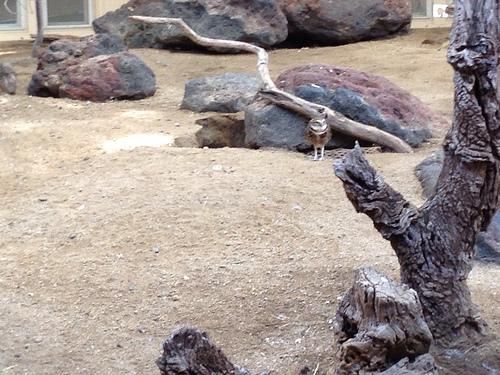Question: how many people are there?
Choices:
A. 0.
B. 1.
C. 2.
D. 3.
Answer with the letter. Answer: A Question: what color is the ground?
Choices:
A. Brown.
B. Grey.
C. Green.
D. Pinky-tan.
Answer with the letter. Answer: A Question: what animal is standing on the ground?
Choices:
A. Squirrel.
B. An owl.
C. Zebra.
D. Sheep.
Answer with the letter. Answer: B Question: what is behind the owl?
Choices:
A. Sky.
B. A limb and some rocks.
C. Barn.
D. Telephone pole.
Answer with the letter. Answer: B Question: what is the weather like?
Choices:
A. Windy.
B. Overcast.
C. Sunny.
D. Stormy.
Answer with the letter. Answer: C 